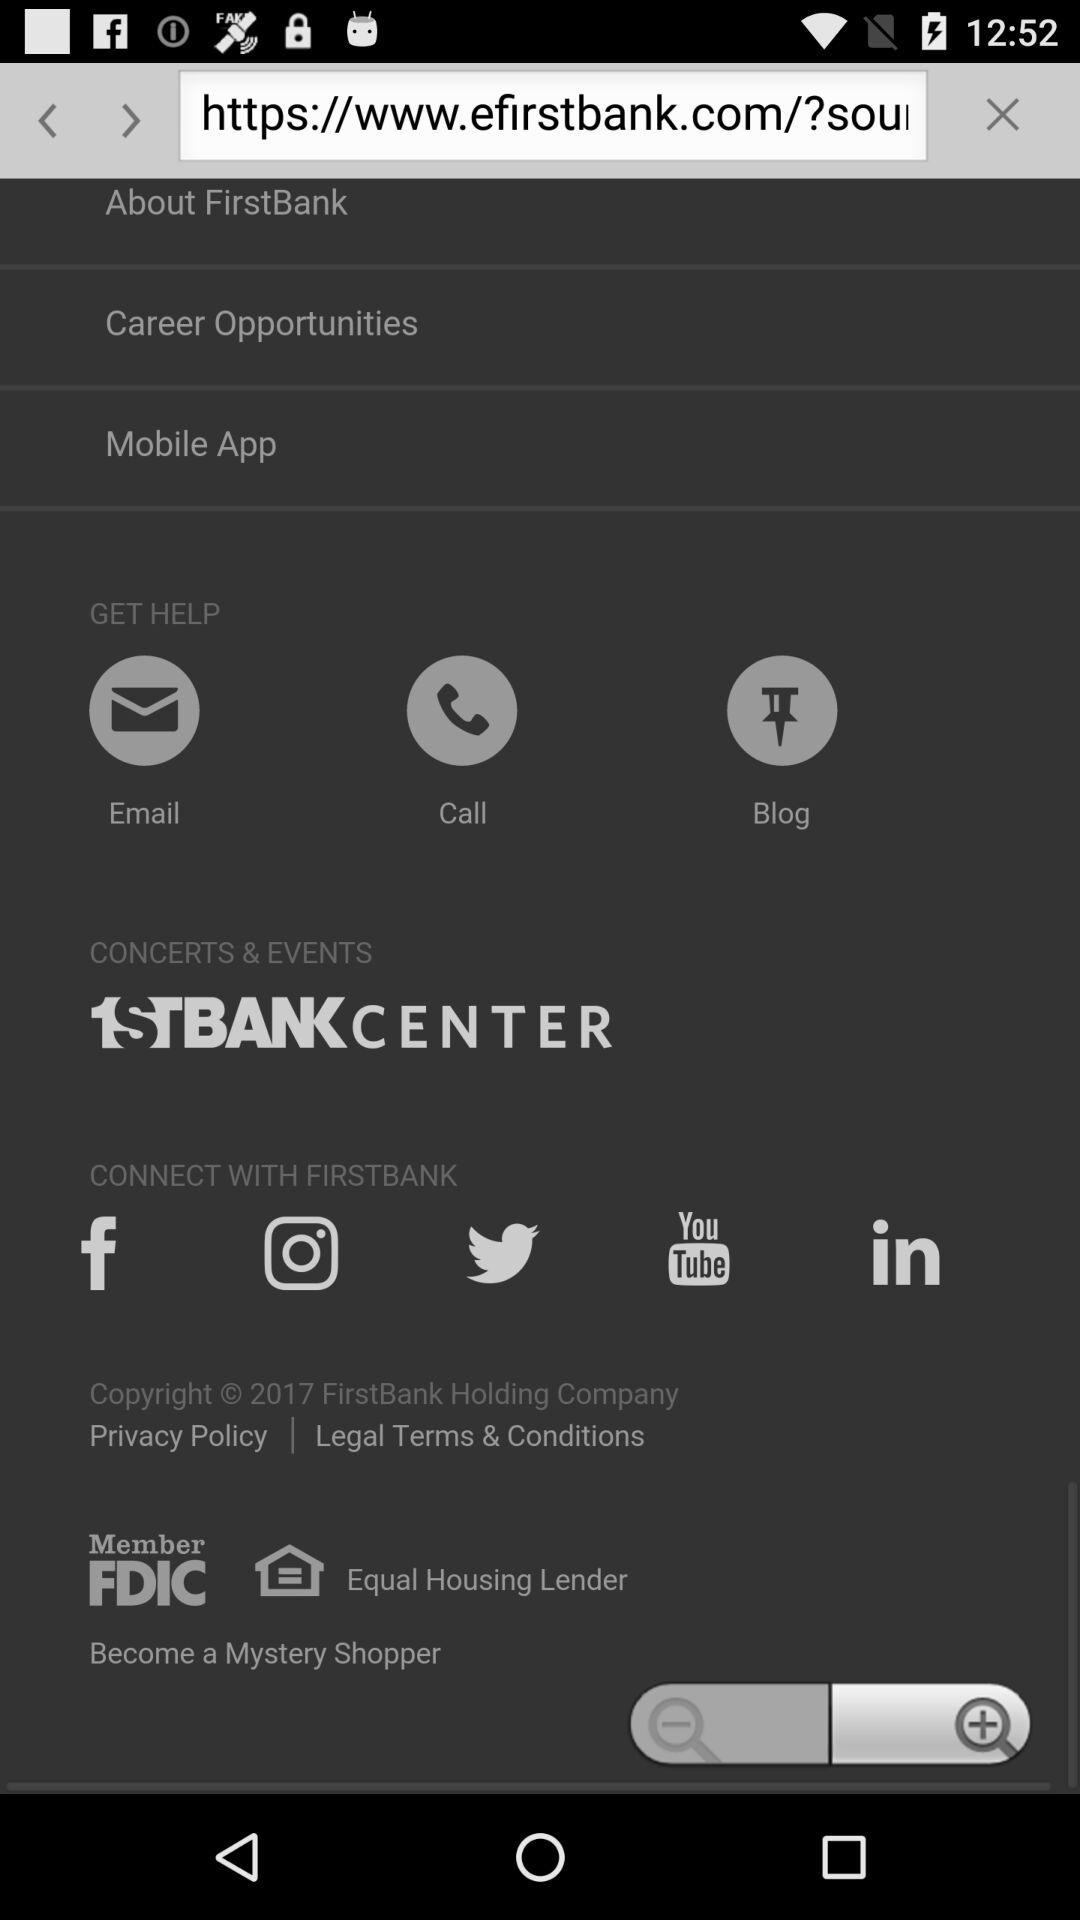What is the bank's email address?
When the provided information is insufficient, respond with <no answer>. <no answer> 